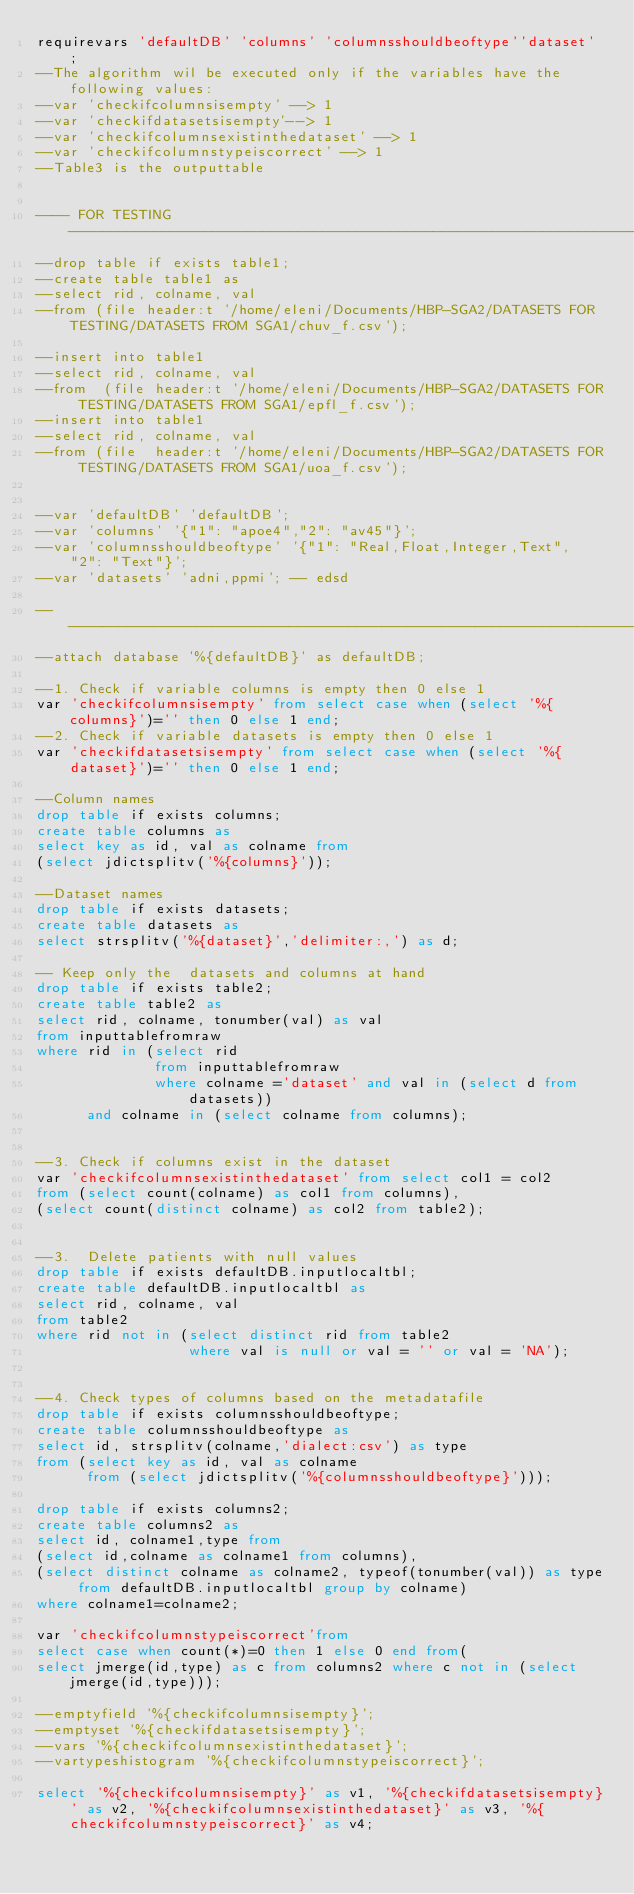Convert code to text. <code><loc_0><loc_0><loc_500><loc_500><_SQL_>requirevars 'defaultDB' 'columns' 'columnsshouldbeoftype''dataset' ;
--The algorithm wil be executed only if the variables have the following values: 
--var 'checkifcolumnsisempty' --> 1 
--var 'checkifdatasetsisempty'--> 1
--var 'checkifcolumnsexistinthedataset' --> 1
--var 'checkifcolumnstypeiscorrect' --> 1
--Table3 is the outputtable


---- FOR TESTING -------------------------------------------------------------------------
--drop table if exists table1;
--create table table1 as 
--select rid, colname, val 
--from (file header:t '/home/eleni/Documents/HBP-SGA2/DATASETS FOR TESTING/DATASETS FROM SGA1/chuv_f.csv');

--insert into table1 
--select rid, colname, val 
--from  (file header:t '/home/eleni/Documents/HBP-SGA2/DATASETS FOR TESTING/DATASETS FROM SGA1/epfl_f.csv');
--insert into table1 
--select rid, colname, val 
--from (file  header:t '/home/eleni/Documents/HBP-SGA2/DATASETS FOR TESTING/DATASETS FROM SGA1/uoa_f.csv');


--var 'defaultDB' 'defaultDB'; 
--var 'columns' '{"1": "apoe4","2": "av45"}';
--var 'columnsshouldbeoftype' '{"1": "Real,Float,Integer,Text", "2": "Text"}';
--var 'datasets' 'adni,ppmi'; -- edsd

------------------------------------------------------------------------------------------
--attach database '%{defaultDB}' as defaultDB;

--1. Check if variable columns is empty then 0 else 1
var 'checkifcolumnsisempty' from select case when (select '%{columns}')='' then 0 else 1 end;
--2. Check if variable datasets is empty then 0 else 1
var 'checkifdatasetsisempty' from select case when (select '%{dataset}')='' then 0 else 1 end;

--Column names
drop table if exists columns;
create table columns as
select key as id, val as colname from 
(select jdictsplitv('%{columns}'));

--Dataset names
drop table if exists datasets;
create table datasets as
select strsplitv('%{dataset}','delimiter:,') as d;

-- Keep only the  datasets and columns at hand
drop table if exists table2; 
create table table2 as
select rid, colname, tonumber(val) as val
from inputtablefromraw
where rid in (select rid
              from inputtablefromraw 
              where colname ='dataset' and val in (select d from datasets))
      and colname in (select colname from columns);


--3. Check if columns exist in the dataset
var 'checkifcolumnsexistinthedataset' from select col1 = col2 
from (select count(colname) as col1 from columns), 
(select count(distinct colname) as col2 from table2);


--3.  Delete patients with null values 
drop table if exists defaultDB.inputlocaltbl;
create table defaultDB.inputlocaltbl as 
select rid, colname, val
from table2
where rid not in (select distinct rid from table2 
                  where val is null or val = '' or val = 'NA');


--4. Check types of columns based on the metadatafile
drop table if exists columnsshouldbeoftype;
create table columnsshouldbeoftype as
select id, strsplitv(colname,'dialect:csv') as type 
from (select key as id, val as colname 
      from (select jdictsplitv('%{columnsshouldbeoftype}')));

drop table if exists columns2;
create table columns2 as
select id, colname1,type from 
(select id,colname as colname1 from columns),
(select distinct colname as colname2, typeof(tonumber(val)) as type from defaultDB.inputlocaltbl group by colname)
where colname1=colname2;

var 'checkifcolumnstypeiscorrect'from
select case when count(*)=0 then 1 else 0 end from(
select jmerge(id,type) as c from columns2 where c not in (select jmerge(id,type)));

--emptyfield '%{checkifcolumnsisempty}';
--emptyset '%{checkifdatasetsisempty}';
--vars '%{checkifcolumnsexistinthedataset}';
--vartypeshistogram '%{checkifcolumnstypeiscorrect}';

select '%{checkifcolumnsisempty}' as v1, '%{checkifdatasetsisempty}' as v2, '%{checkifcolumnsexistinthedataset}' as v3, '%{checkifcolumnstypeiscorrect}' as v4;




</code> 